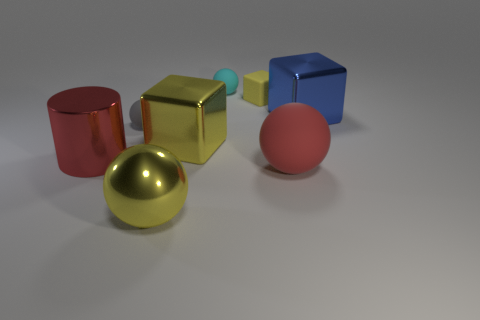Are there any other things that have the same size as the blue shiny thing?
Give a very brief answer. Yes. There is a large yellow thing that is the same shape as the blue object; what material is it?
Your answer should be compact. Metal. Is there a big shiny ball that is right of the matte sphere that is in front of the big block left of the red rubber ball?
Ensure brevity in your answer.  No. Do the large metallic thing that is on the left side of the metallic sphere and the large red thing on the right side of the yellow sphere have the same shape?
Keep it short and to the point. No. Is the number of red rubber spheres that are to the right of the red ball greater than the number of tiny gray rubber objects?
Provide a succinct answer. No. What number of things are small cyan things or red metal cylinders?
Your response must be concise. 2. The cylinder is what color?
Your answer should be compact. Red. What number of other objects are the same color as the rubber block?
Provide a succinct answer. 2. Are there any blue things behind the matte block?
Ensure brevity in your answer.  No. The tiny thing in front of the big metallic thing right of the large cube that is on the left side of the big blue block is what color?
Offer a terse response. Gray. 